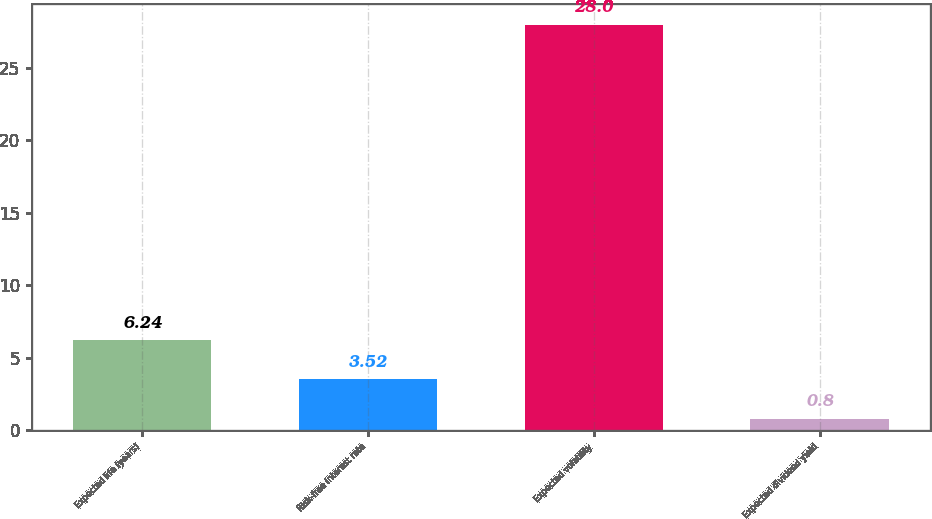<chart> <loc_0><loc_0><loc_500><loc_500><bar_chart><fcel>Expected life (years)<fcel>Risk-free interest rate<fcel>Expected volatility<fcel>Expected dividend yield<nl><fcel>6.24<fcel>3.52<fcel>28<fcel>0.8<nl></chart> 